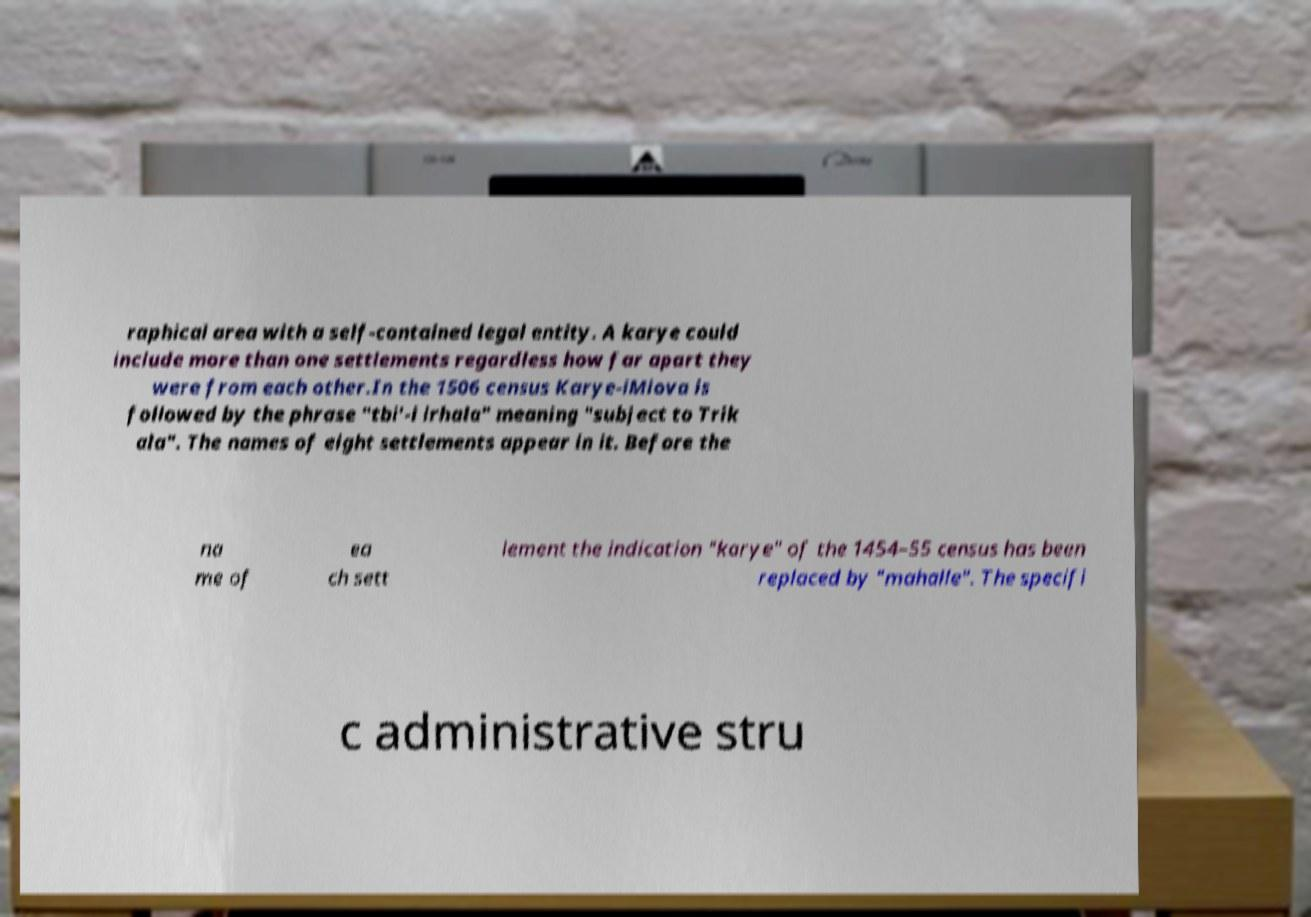Could you extract and type out the text from this image? raphical area with a self-contained legal entity. A karye could include more than one settlements regardless how far apart they were from each other.In the 1506 census Karye-iMiova is followed by the phrase "tbi'-i irhala" meaning "subject to Trik ala". The names of eight settlements appear in it. Before the na me of ea ch sett lement the indication "karye" of the 1454–55 census has been replaced by "mahalle". The specifi c administrative stru 